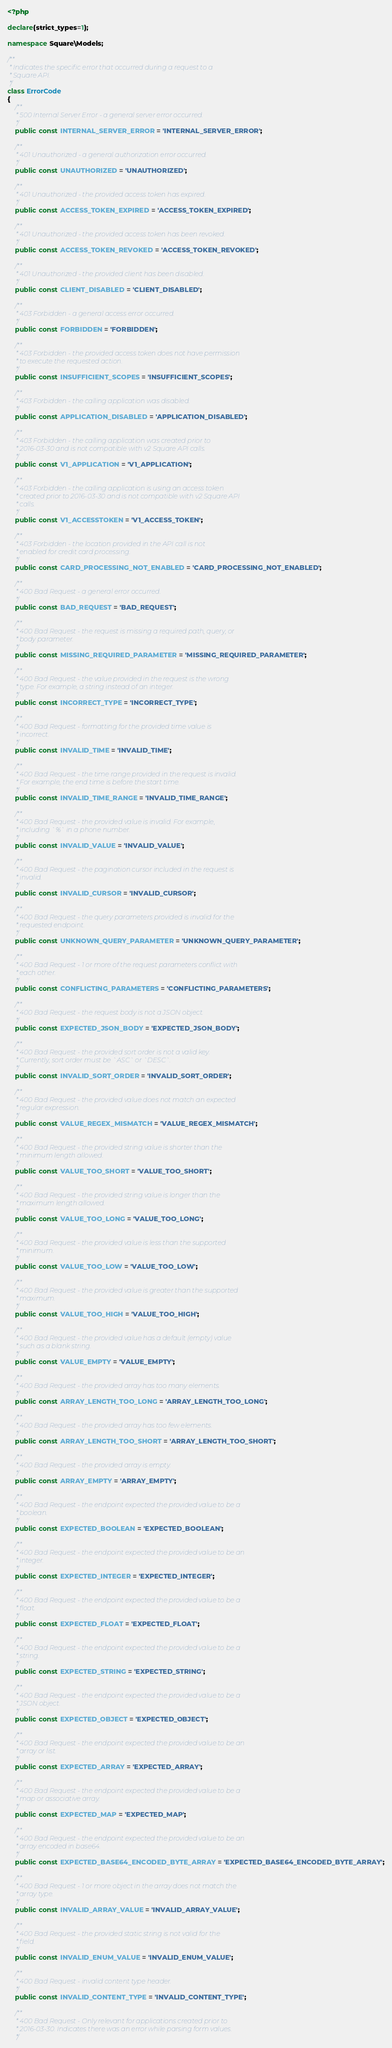Convert code to text. <code><loc_0><loc_0><loc_500><loc_500><_PHP_><?php

declare(strict_types=1);

namespace Square\Models;

/**
 * Indicates the specific error that occurred during a request to a
 * Square API.
 */
class ErrorCode
{
    /**
     * 500 Internal Server Error - a general server error occurred.
     */
    public const INTERNAL_SERVER_ERROR = 'INTERNAL_SERVER_ERROR';

    /**
     * 401 Unauthorized - a general authorization error occurred.
     */
    public const UNAUTHORIZED = 'UNAUTHORIZED';

    /**
     * 401 Unauthorized - the provided access token has expired.
     */
    public const ACCESS_TOKEN_EXPIRED = 'ACCESS_TOKEN_EXPIRED';

    /**
     * 401 Unauthorized - the provided access token has been revoked.
     */
    public const ACCESS_TOKEN_REVOKED = 'ACCESS_TOKEN_REVOKED';

    /**
     * 401 Unauthorized - the provided client has been disabled.
     */
    public const CLIENT_DISABLED = 'CLIENT_DISABLED';

    /**
     * 403 Forbidden - a general access error occurred.
     */
    public const FORBIDDEN = 'FORBIDDEN';

    /**
     * 403 Forbidden - the provided access token does not have permission
     * to execute the requested action.
     */
    public const INSUFFICIENT_SCOPES = 'INSUFFICIENT_SCOPES';

    /**
     * 403 Forbidden - the calling application was disabled.
     */
    public const APPLICATION_DISABLED = 'APPLICATION_DISABLED';

    /**
     * 403 Forbidden - the calling application was created prior to
     * 2016-03-30 and is not compatible with v2 Square API calls.
     */
    public const V1_APPLICATION = 'V1_APPLICATION';

    /**
     * 403 Forbidden - the calling application is using an access token
     * created prior to 2016-03-30 and is not compatible with v2 Square API
     * calls.
     */
    public const V1_ACCESSTOKEN = 'V1_ACCESS_TOKEN';

    /**
     * 403 Forbidden - the location provided in the API call is not
     * enabled for credit card processing.
     */
    public const CARD_PROCESSING_NOT_ENABLED = 'CARD_PROCESSING_NOT_ENABLED';

    /**
     * 400 Bad Request - a general error occurred.
     */
    public const BAD_REQUEST = 'BAD_REQUEST';

    /**
     * 400 Bad Request - the request is missing a required path, query, or
     * body parameter.
     */
    public const MISSING_REQUIRED_PARAMETER = 'MISSING_REQUIRED_PARAMETER';

    /**
     * 400 Bad Request - the value provided in the request is the wrong
     * type. For example, a string instead of an integer.
     */
    public const INCORRECT_TYPE = 'INCORRECT_TYPE';

    /**
     * 400 Bad Request - formatting for the provided time value is
     * incorrect.
     */
    public const INVALID_TIME = 'INVALID_TIME';

    /**
     * 400 Bad Request - the time range provided in the request is invalid.
     * For example, the end time is before the start time.
     */
    public const INVALID_TIME_RANGE = 'INVALID_TIME_RANGE';

    /**
     * 400 Bad Request - the provided value is invalid. For example,
     * including `%` in a phone number.
     */
    public const INVALID_VALUE = 'INVALID_VALUE';

    /**
     * 400 Bad Request - the pagination cursor included in the request is
     * invalid.
     */
    public const INVALID_CURSOR = 'INVALID_CURSOR';

    /**
     * 400 Bad Request - the query parameters provided is invalid for the
     * requested endpoint.
     */
    public const UNKNOWN_QUERY_PARAMETER = 'UNKNOWN_QUERY_PARAMETER';

    /**
     * 400 Bad Request - 1 or more of the request parameters conflict with
     * each other.
     */
    public const CONFLICTING_PARAMETERS = 'CONFLICTING_PARAMETERS';

    /**
     * 400 Bad Request - the request body is not a JSON object.
     */
    public const EXPECTED_JSON_BODY = 'EXPECTED_JSON_BODY';

    /**
     * 400 Bad Request - the provided sort order is not a valid key.
     * Currently, sort order must be `ASC` or `DESC`.
     */
    public const INVALID_SORT_ORDER = 'INVALID_SORT_ORDER';

    /**
     * 400 Bad Request - the provided value does not match an expected
     * regular expression.
     */
    public const VALUE_REGEX_MISMATCH = 'VALUE_REGEX_MISMATCH';

    /**
     * 400 Bad Request - the provided string value is shorter than the
     * minimum length allowed.
     */
    public const VALUE_TOO_SHORT = 'VALUE_TOO_SHORT';

    /**
     * 400 Bad Request - the provided string value is longer than the
     * maximum length allowed.
     */
    public const VALUE_TOO_LONG = 'VALUE_TOO_LONG';

    /**
     * 400 Bad Request - the provided value is less than the supported
     * minimum.
     */
    public const VALUE_TOO_LOW = 'VALUE_TOO_LOW';

    /**
     * 400 Bad Request - the provided value is greater than the supported
     * maximum.
     */
    public const VALUE_TOO_HIGH = 'VALUE_TOO_HIGH';

    /**
     * 400 Bad Request - the provided value has a default (empty) value
     * such as a blank string.
     */
    public const VALUE_EMPTY = 'VALUE_EMPTY';

    /**
     * 400 Bad Request - the provided array has too many elements.
     */
    public const ARRAY_LENGTH_TOO_LONG = 'ARRAY_LENGTH_TOO_LONG';

    /**
     * 400 Bad Request - the provided array has too few elements.
     */
    public const ARRAY_LENGTH_TOO_SHORT = 'ARRAY_LENGTH_TOO_SHORT';

    /**
     * 400 Bad Request - the provided array is empty.
     */
    public const ARRAY_EMPTY = 'ARRAY_EMPTY';

    /**
     * 400 Bad Request - the endpoint expected the provided value to be a
     * boolean.
     */
    public const EXPECTED_BOOLEAN = 'EXPECTED_BOOLEAN';

    /**
     * 400 Bad Request - the endpoint expected the provided value to be an
     * integer.
     */
    public const EXPECTED_INTEGER = 'EXPECTED_INTEGER';

    /**
     * 400 Bad Request - the endpoint expected the provided value to be a
     * float.
     */
    public const EXPECTED_FLOAT = 'EXPECTED_FLOAT';

    /**
     * 400 Bad Request - the endpoint expected the provided value to be a
     * string.
     */
    public const EXPECTED_STRING = 'EXPECTED_STRING';

    /**
     * 400 Bad Request - the endpoint expected the provided value to be a
     * JSON object.
     */
    public const EXPECTED_OBJECT = 'EXPECTED_OBJECT';

    /**
     * 400 Bad Request - the endpoint expected the provided value to be an
     * array or list.
     */
    public const EXPECTED_ARRAY = 'EXPECTED_ARRAY';

    /**
     * 400 Bad Request - the endpoint expected the provided value to be a
     * map or associative array.
     */
    public const EXPECTED_MAP = 'EXPECTED_MAP';

    /**
     * 400 Bad Request - the endpoint expected the provided value to be an
     * array encoded in base64.
     */
    public const EXPECTED_BASE64_ENCODED_BYTE_ARRAY = 'EXPECTED_BASE64_ENCODED_BYTE_ARRAY';

    /**
     * 400 Bad Request - 1 or more object in the array does not match the
     * array type.
     */
    public const INVALID_ARRAY_VALUE = 'INVALID_ARRAY_VALUE';

    /**
     * 400 Bad Request - the provided static string is not valid for the
     * field.
     */
    public const INVALID_ENUM_VALUE = 'INVALID_ENUM_VALUE';

    /**
     * 400 Bad Request - invalid content type header.
     */
    public const INVALID_CONTENT_TYPE = 'INVALID_CONTENT_TYPE';

    /**
     * 400 Bad Request - Only relevant for applications created prior to
     * 2016-03-30. Indicates there was an error while parsing form values.
     */</code> 